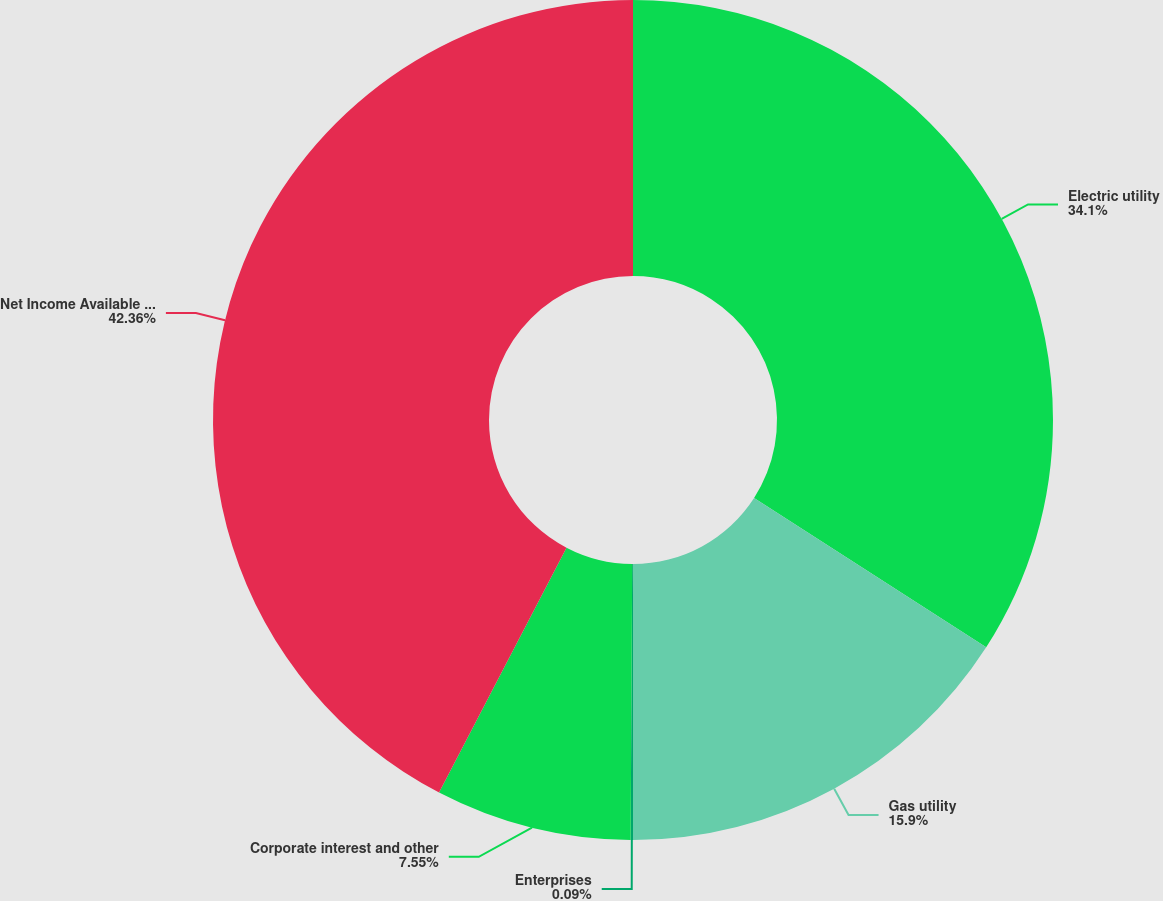Convert chart. <chart><loc_0><loc_0><loc_500><loc_500><pie_chart><fcel>Electric utility<fcel>Gas utility<fcel>Enterprises<fcel>Corporate interest and other<fcel>Net Income Available to Common<nl><fcel>34.1%<fcel>15.9%<fcel>0.09%<fcel>7.55%<fcel>42.36%<nl></chart> 